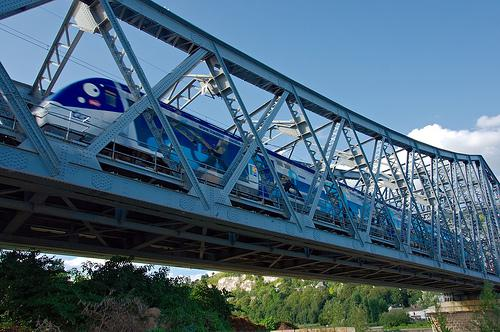Question: where was the photo taken?
Choices:
A. Train tracks.
B. Dirt road.
C. Bus stop.
D. A street.
Answer with the letter. Answer: A Question: what is in the sky?
Choices:
A. Birds.
B. Plane.
C. Kites.
D. Clouds.
Answer with the letter. Answer: D Question: where is a train?
Choices:
A. On the tracks.
B. On a bridge.
C. Train station.
D. Scrap yard.
Answer with the letter. Answer: B Question: what is blue?
Choices:
A. Ocean.
B. Sign.
C. Car.
D. Sky.
Answer with the letter. Answer: D Question: what is green?
Choices:
A. Trees.
B. Grass.
C. Sign.
D. Car.
Answer with the letter. Answer: A 